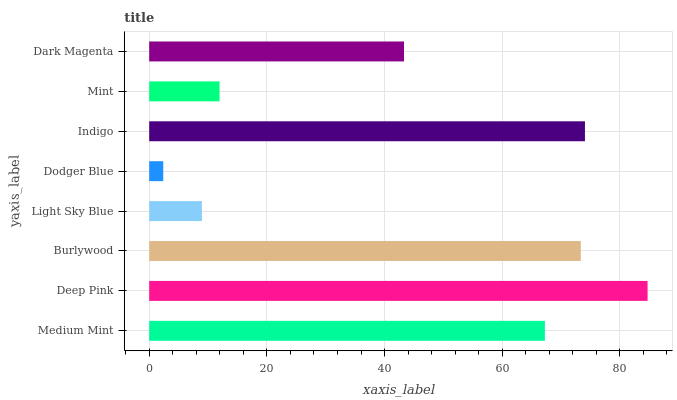Is Dodger Blue the minimum?
Answer yes or no. Yes. Is Deep Pink the maximum?
Answer yes or no. Yes. Is Burlywood the minimum?
Answer yes or no. No. Is Burlywood the maximum?
Answer yes or no. No. Is Deep Pink greater than Burlywood?
Answer yes or no. Yes. Is Burlywood less than Deep Pink?
Answer yes or no. Yes. Is Burlywood greater than Deep Pink?
Answer yes or no. No. Is Deep Pink less than Burlywood?
Answer yes or no. No. Is Medium Mint the high median?
Answer yes or no. Yes. Is Dark Magenta the low median?
Answer yes or no. Yes. Is Light Sky Blue the high median?
Answer yes or no. No. Is Deep Pink the low median?
Answer yes or no. No. 